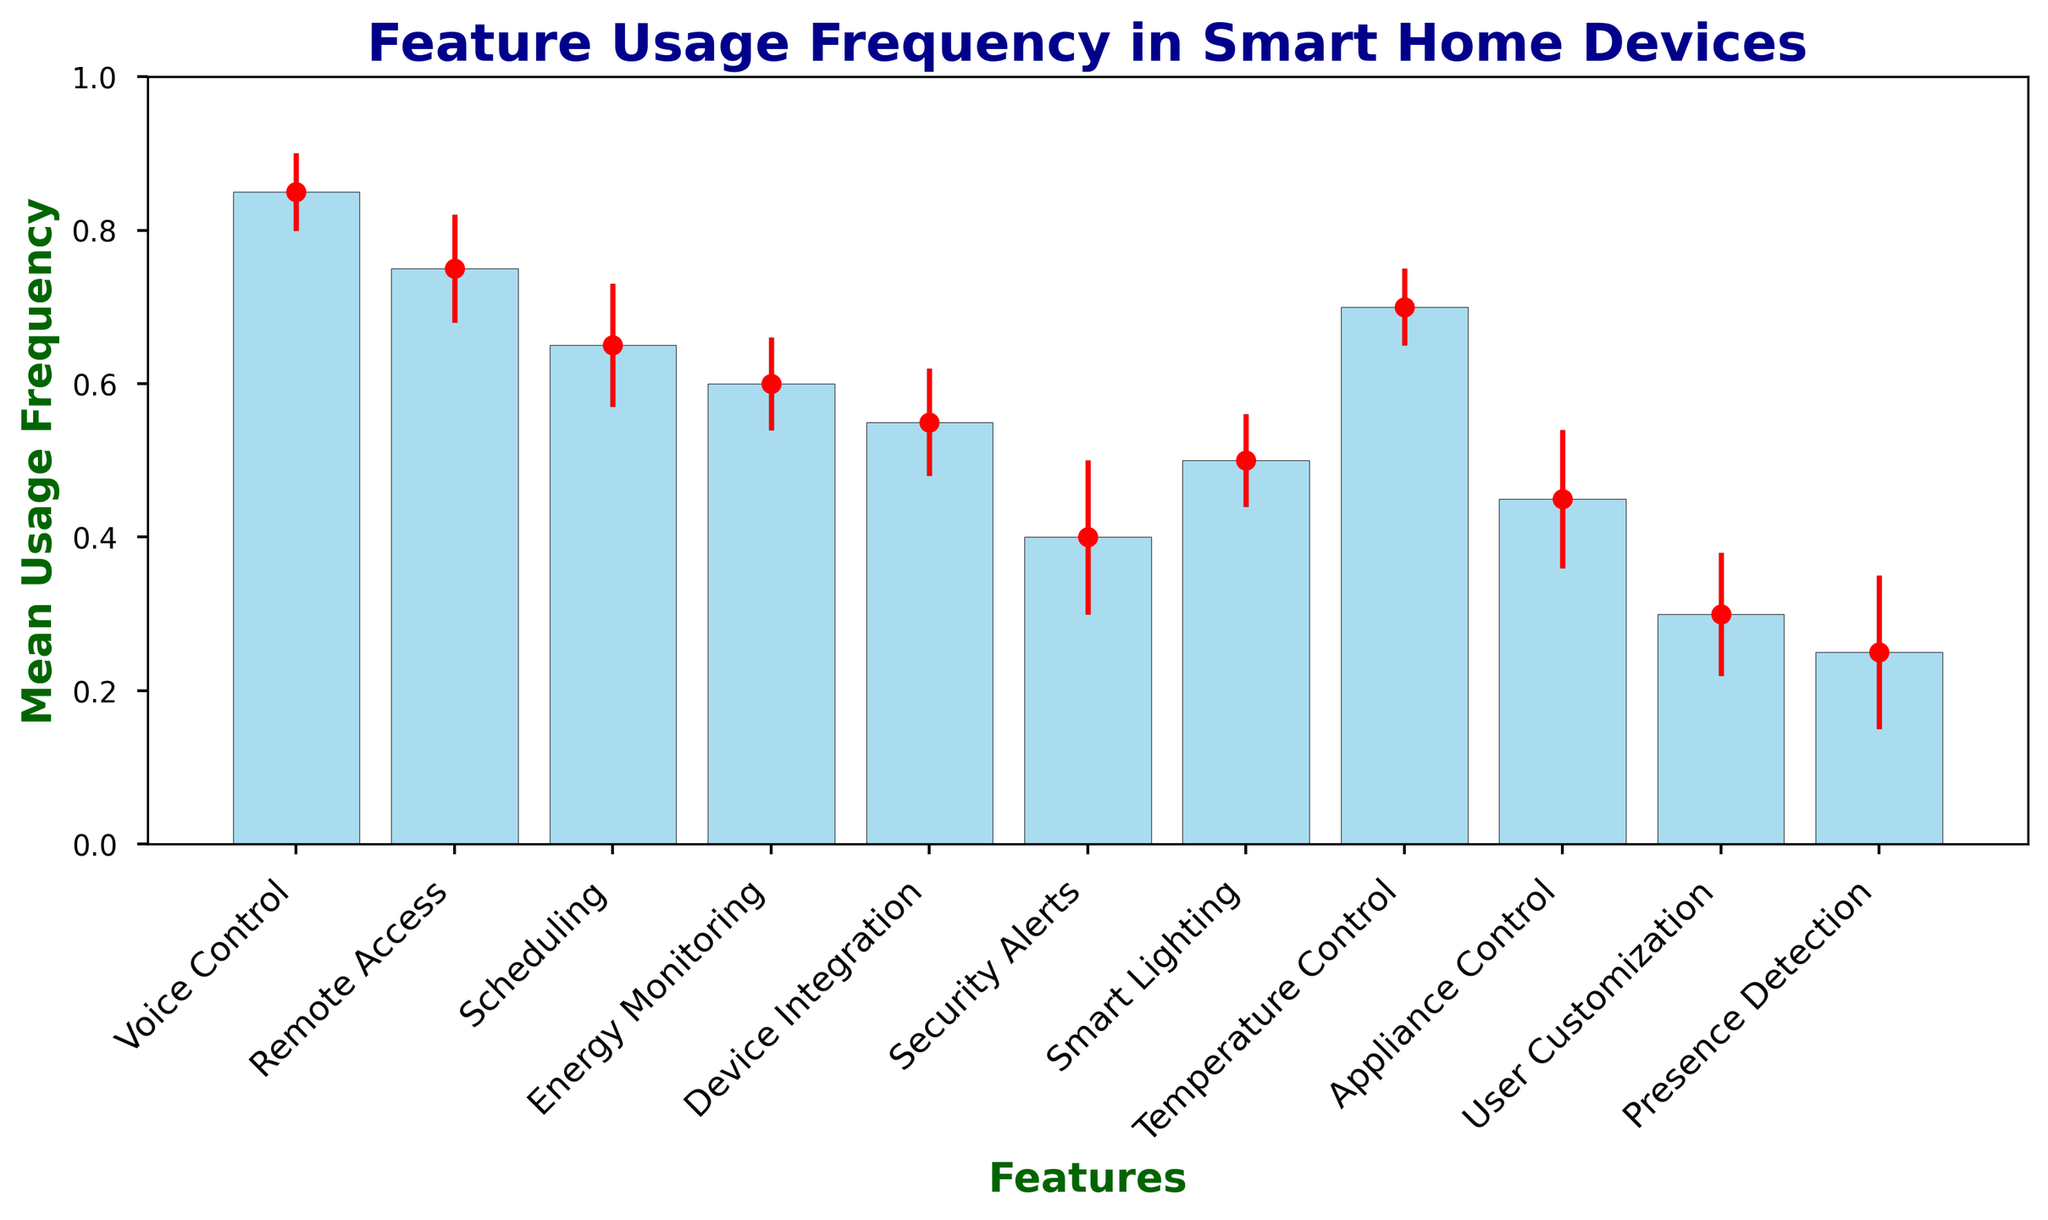Which feature has the highest mean usage frequency? The bar with the highest position in the chart represents the feature with the highest mean usage frequency. According to the chart, "Voice Control" has the highest bar.
Answer: Voice Control What is the difference in mean usage frequency between "Voice Control" and "Security Alerts"? Find the mean usage frequencies of both features and subtract the smaller from the larger. "Voice Control" has a mean usage frequency of 0.85, and "Security Alerts" has a mean usage frequency of 0.40. Therefore, 0.85 - 0.40 = 0.45
Answer: 0.45 Which feature has the largest error (standard deviation)? The lengths of the error bars indicate the standard deviations. "Security Alerts" has the longest error bar, indicating the largest error of 0.10.
Answer: Security Alerts How many features have a mean usage frequency greater than 0.60? Identify and count the bars that exceed the 0.60 mark. "Voice Control," "Remote Access," "Temperature Control," and "Scheduling" all have mean usage frequencies above 0.60.
Answer: 4 Is the mean usage frequency of "Appliance Control" greater than or less than "Device Integration"? Compare the heights of the bars for both features. "Device Integration" has a mean usage frequency of 0.55, while "Appliance Control" has 0.45.
Answer: Less than What is the average mean usage frequency of "Energy Monitoring" and "User Customization"? Add the mean usage frequencies of both features and divide by 2. "Energy Monitoring" has a mean usage frequency of 0.60, and "User Customization" has 0.30. Therefore, (0.60 + 0.30) / 2 = 0.45
Answer: 0.45 Which feature has a mean usage frequency closest to 0.50? Identify the bar closest to the 0.50 mark. "Smart Lighting" has a mean usage frequency almost exactly at 0.50.
Answer: Smart Lighting Arrange the features "Scheduling," "Energy Monitoring," and "Remote Access" in descending order of their mean usage frequency. Compare the mean usage frequencies of the three features. "Remote Access" has 0.75, "Scheduling" has 0.65, and "Energy Monitoring" has 0.60. Therefore, the order is "Remote Access," "Scheduling," "Energy Monitoring."
Answer: Remote Access, Scheduling, Energy Monitoring Which features have an error (standard deviation) of 0.07? Identify the bars with error bars of length 0.07. "Remote Access" and "Device Integration" both have an error of 0.07.
Answer: Remote Access, Device Integration 